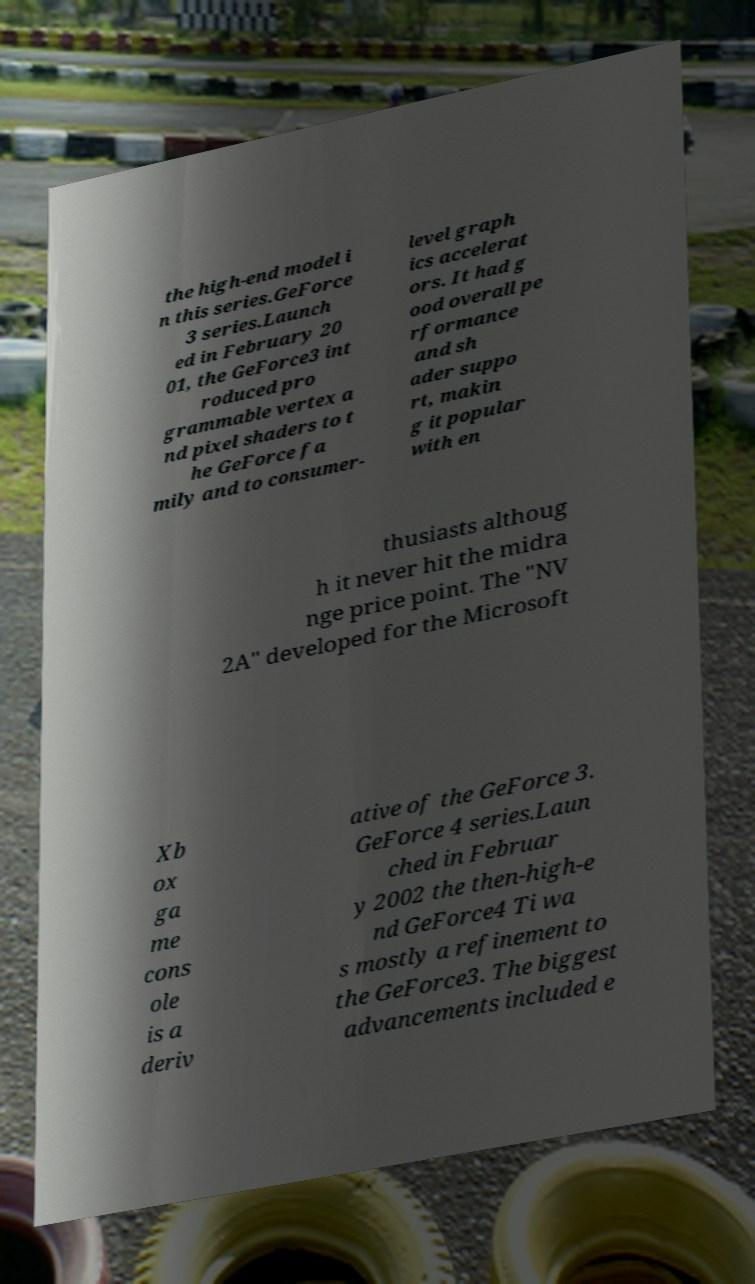What messages or text are displayed in this image? I need them in a readable, typed format. the high-end model i n this series.GeForce 3 series.Launch ed in February 20 01, the GeForce3 int roduced pro grammable vertex a nd pixel shaders to t he GeForce fa mily and to consumer- level graph ics accelerat ors. It had g ood overall pe rformance and sh ader suppo rt, makin g it popular with en thusiasts althoug h it never hit the midra nge price point. The "NV 2A" developed for the Microsoft Xb ox ga me cons ole is a deriv ative of the GeForce 3. GeForce 4 series.Laun ched in Februar y 2002 the then-high-e nd GeForce4 Ti wa s mostly a refinement to the GeForce3. The biggest advancements included e 